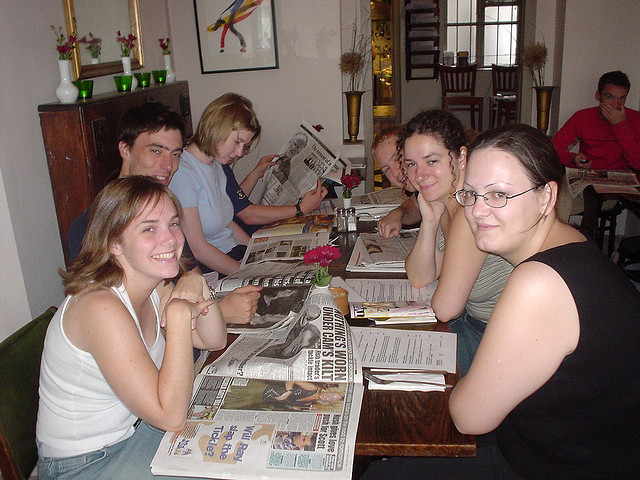What are the people doing in the image? The group of people seems to be engaged in reading newspapers and looking through menus, likely making meal choices or catching up on news while waiting for their order. 